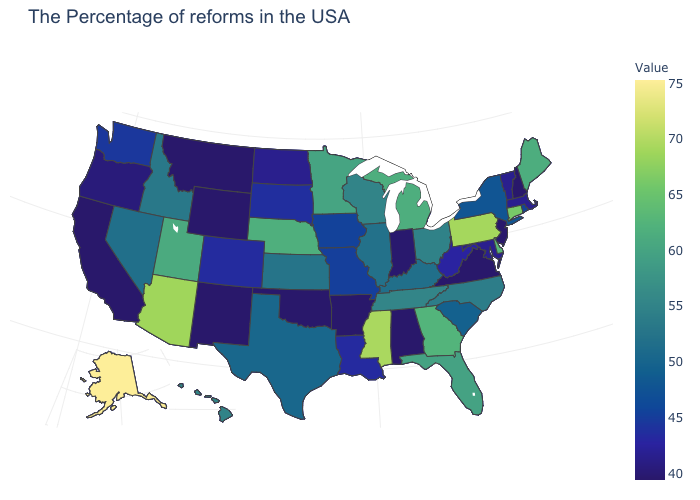Does Vermont have a higher value than Delaware?
Answer briefly. No. Does the map have missing data?
Answer briefly. No. Which states have the highest value in the USA?
Be succinct. Alaska. Which states have the lowest value in the South?
Write a very short answer. Virginia, Alabama, Arkansas, Oklahoma. Does Mississippi have the highest value in the South?
Quick response, please. Yes. Among the states that border Washington , which have the highest value?
Answer briefly. Idaho. Does Arizona have the lowest value in the West?
Concise answer only. No. Which states have the lowest value in the Northeast?
Concise answer only. New Hampshire, New Jersey. 